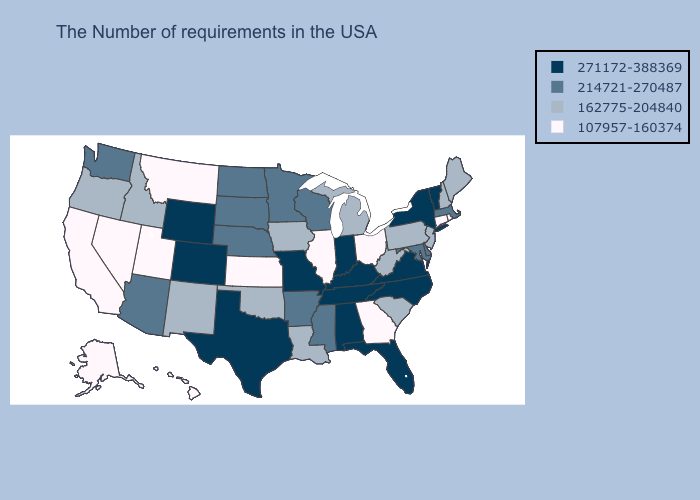What is the lowest value in the Northeast?
Quick response, please. 107957-160374. Among the states that border Massachusetts , does Connecticut have the lowest value?
Quick response, please. Yes. What is the value of Missouri?
Answer briefly. 271172-388369. Does Florida have a lower value than Virginia?
Keep it brief. No. Name the states that have a value in the range 107957-160374?
Give a very brief answer. Rhode Island, Connecticut, Ohio, Georgia, Illinois, Kansas, Utah, Montana, Nevada, California, Alaska, Hawaii. What is the value of Missouri?
Quick response, please. 271172-388369. Name the states that have a value in the range 214721-270487?
Concise answer only. Massachusetts, Delaware, Maryland, Wisconsin, Mississippi, Arkansas, Minnesota, Nebraska, South Dakota, North Dakota, Arizona, Washington. Does the first symbol in the legend represent the smallest category?
Quick response, please. No. What is the lowest value in the West?
Be succinct. 107957-160374. Among the states that border Tennessee , which have the highest value?
Quick response, please. Virginia, North Carolina, Kentucky, Alabama, Missouri. Which states have the highest value in the USA?
Be succinct. Vermont, New York, Virginia, North Carolina, Florida, Kentucky, Indiana, Alabama, Tennessee, Missouri, Texas, Wyoming, Colorado. Is the legend a continuous bar?
Write a very short answer. No. What is the value of Kansas?
Answer briefly. 107957-160374. What is the value of Minnesota?
Write a very short answer. 214721-270487. What is the lowest value in states that border South Carolina?
Concise answer only. 107957-160374. 